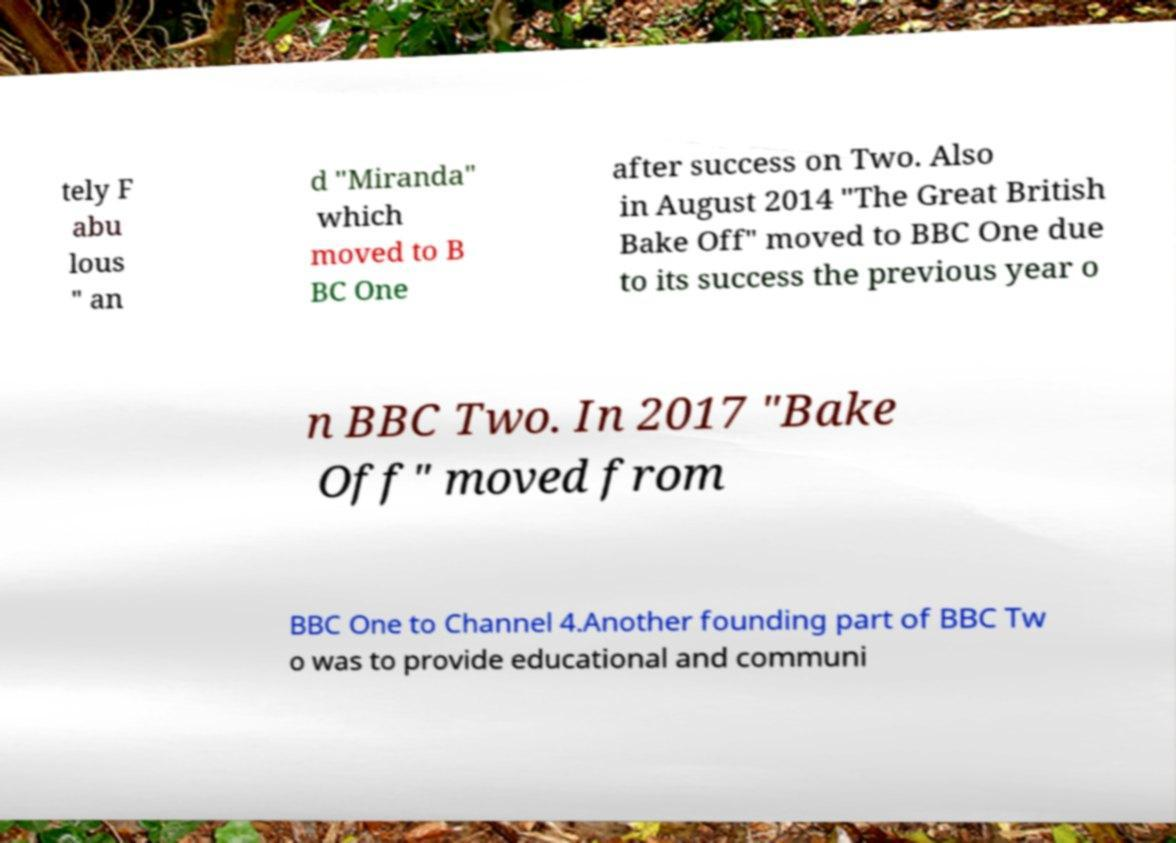Can you accurately transcribe the text from the provided image for me? tely F abu lous " an d "Miranda" which moved to B BC One after success on Two. Also in August 2014 "The Great British Bake Off" moved to BBC One due to its success the previous year o n BBC Two. In 2017 "Bake Off" moved from BBC One to Channel 4.Another founding part of BBC Tw o was to provide educational and communi 